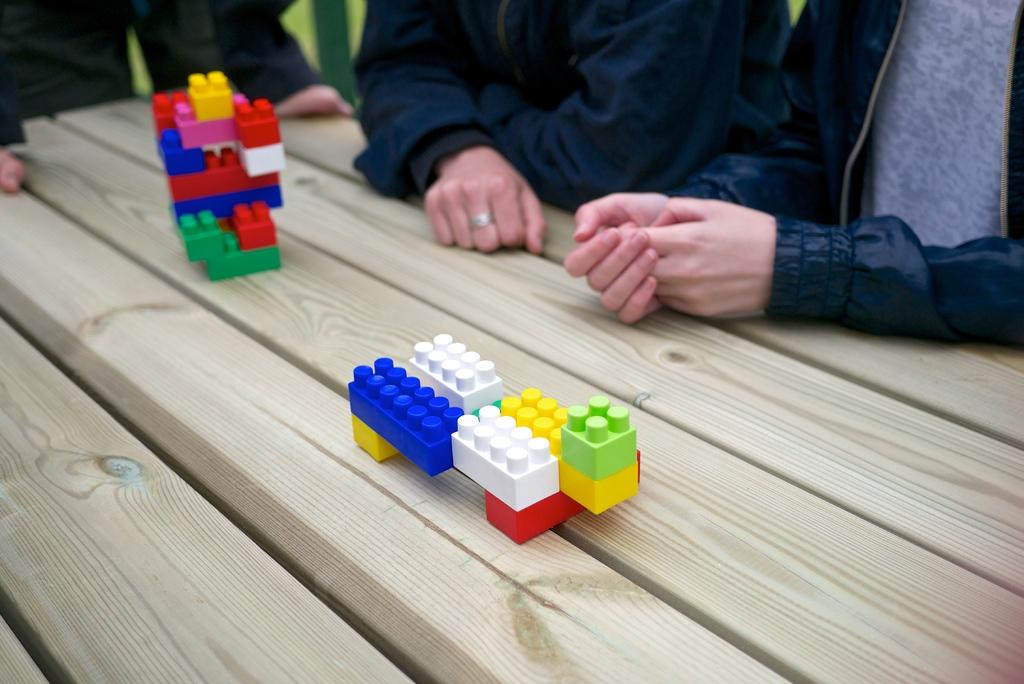What objects are on the table in the image? There are building blocks on the table. Can you describe the people visible in the image? Unfortunately, the facts provided do not give any details about the people in the image. What type of bun is being used as a territory marker by the writer in the image? There is no bun or writer present in the image. 